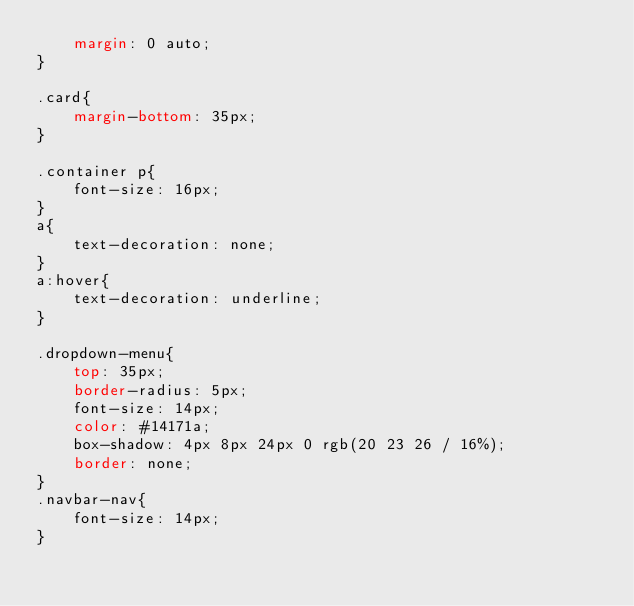<code> <loc_0><loc_0><loc_500><loc_500><_CSS_>    margin: 0 auto;
}

.card{
    margin-bottom: 35px;
}

.container p{
    font-size: 16px;
}
a{
    text-decoration: none;
}
a:hover{
    text-decoration: underline;
}

.dropdown-menu{
    top: 35px;
    border-radius: 5px;
    font-size: 14px;
    color: #14171a;
    box-shadow: 4px 8px 24px 0 rgb(20 23 26 / 16%);
    border: none;
}
.navbar-nav{
    font-size: 14px;
}</code> 